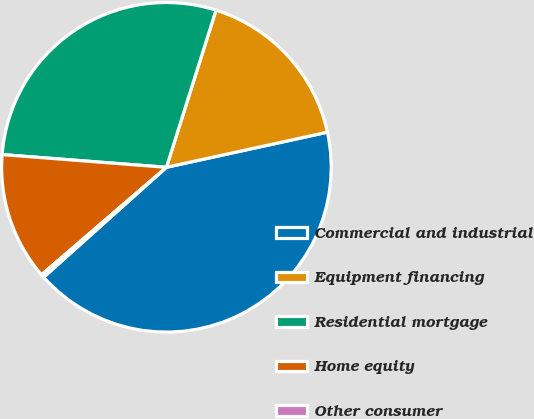Convert chart. <chart><loc_0><loc_0><loc_500><loc_500><pie_chart><fcel>Commercial and industrial<fcel>Equipment financing<fcel>Residential mortgage<fcel>Home equity<fcel>Other consumer<nl><fcel>41.8%<fcel>16.72%<fcel>28.64%<fcel>12.54%<fcel>0.31%<nl></chart> 